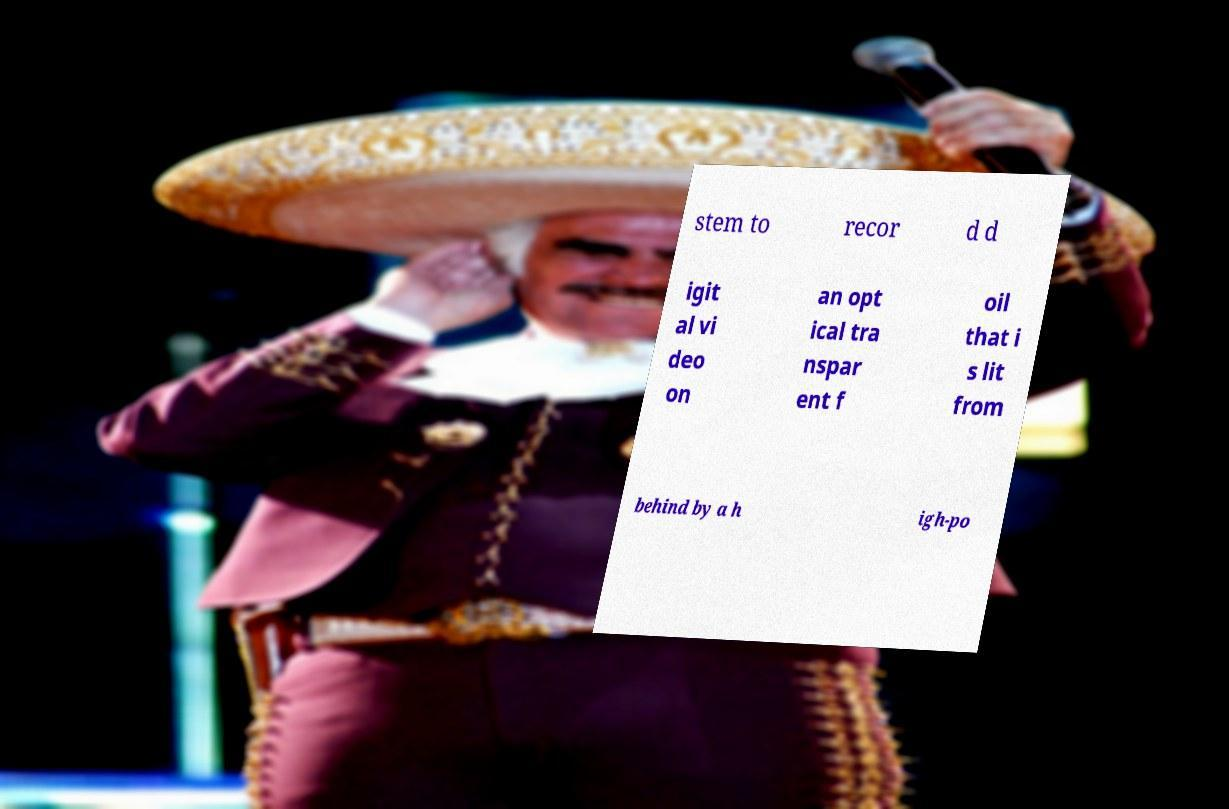Please read and relay the text visible in this image. What does it say? stem to recor d d igit al vi deo on an opt ical tra nspar ent f oil that i s lit from behind by a h igh-po 